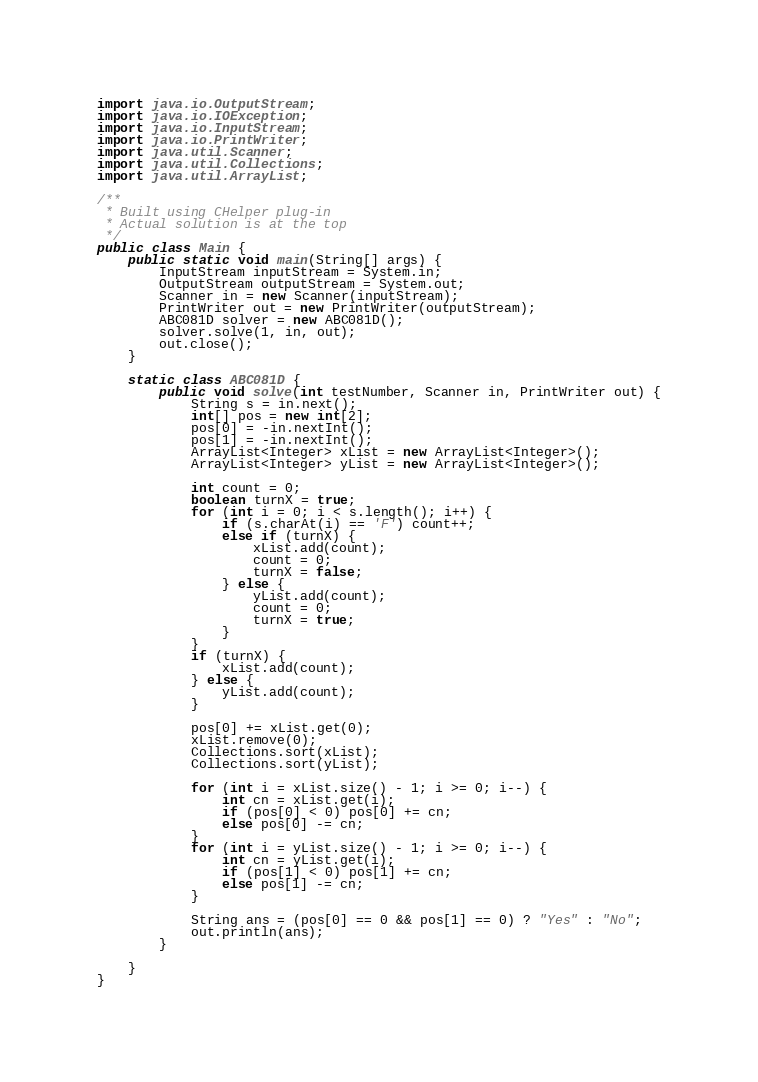<code> <loc_0><loc_0><loc_500><loc_500><_Java_>import java.io.OutputStream;
import java.io.IOException;
import java.io.InputStream;
import java.io.PrintWriter;
import java.util.Scanner;
import java.util.Collections;
import java.util.ArrayList;

/**
 * Built using CHelper plug-in
 * Actual solution is at the top
 */
public class Main {
    public static void main(String[] args) {
        InputStream inputStream = System.in;
        OutputStream outputStream = System.out;
        Scanner in = new Scanner(inputStream);
        PrintWriter out = new PrintWriter(outputStream);
        ABC081D solver = new ABC081D();
        solver.solve(1, in, out);
        out.close();
    }

    static class ABC081D {
        public void solve(int testNumber, Scanner in, PrintWriter out) {
            String s = in.next();
            int[] pos = new int[2];
            pos[0] = -in.nextInt();
            pos[1] = -in.nextInt();
            ArrayList<Integer> xList = new ArrayList<Integer>();
            ArrayList<Integer> yList = new ArrayList<Integer>();

            int count = 0;
            boolean turnX = true;
            for (int i = 0; i < s.length(); i++) {
                if (s.charAt(i) == 'F') count++;
                else if (turnX) {
                    xList.add(count);
                    count = 0;
                    turnX = false;
                } else {
                    yList.add(count);
                    count = 0;
                    turnX = true;
                }
            }
            if (turnX) {
                xList.add(count);
            } else {
                yList.add(count);
            }

            pos[0] += xList.get(0);
            xList.remove(0);
            Collections.sort(xList);
            Collections.sort(yList);

            for (int i = xList.size() - 1; i >= 0; i--) {
                int cn = xList.get(i);
                if (pos[0] < 0) pos[0] += cn;
                else pos[0] -= cn;
            }
            for (int i = yList.size() - 1; i >= 0; i--) {
                int cn = yList.get(i);
                if (pos[1] < 0) pos[1] += cn;
                else pos[1] -= cn;
            }

            String ans = (pos[0] == 0 && pos[1] == 0) ? "Yes" : "No";
            out.println(ans);
        }

    }
}

</code> 